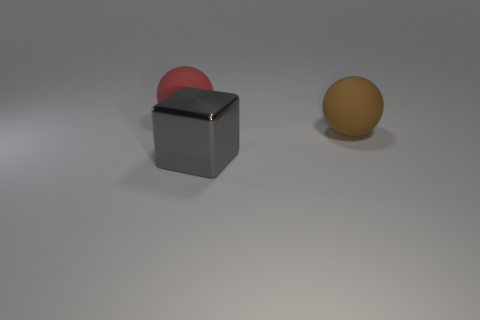What time of day does the lighting in the image suggest? The lighting in the image does not strongly suggest any particular time of day, given that it appears to be an artificial or studio lighting rather than natural sunlight. The soft shadows and diffused lighting hint at an indoor setting perhaps illuminated by overhead lights. 